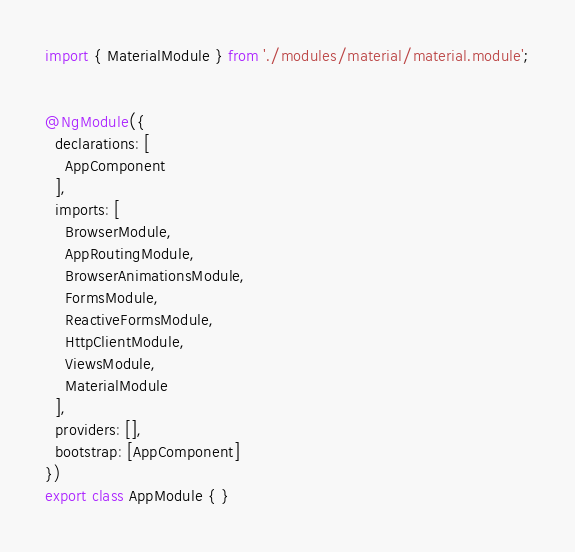Convert code to text. <code><loc_0><loc_0><loc_500><loc_500><_TypeScript_>import { MaterialModule } from './modules/material/material.module';


@NgModule({
  declarations: [
    AppComponent
  ],
  imports: [
    BrowserModule,
    AppRoutingModule,
    BrowserAnimationsModule,
    FormsModule,
    ReactiveFormsModule,
    HttpClientModule,
    ViewsModule,
    MaterialModule
  ],
  providers: [],
  bootstrap: [AppComponent]
})
export class AppModule { }
</code> 